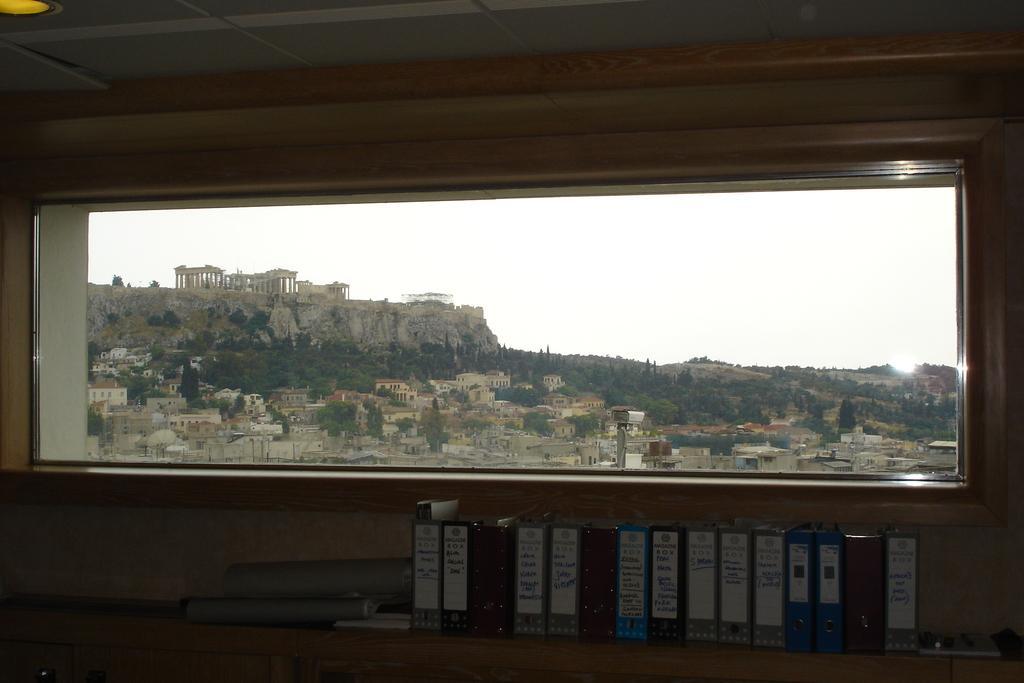Please provide a concise description of this image. In this picture we can see some files at the bottom, there is a glass in the middle, from the glass we can see buildings, trees and the sky. 